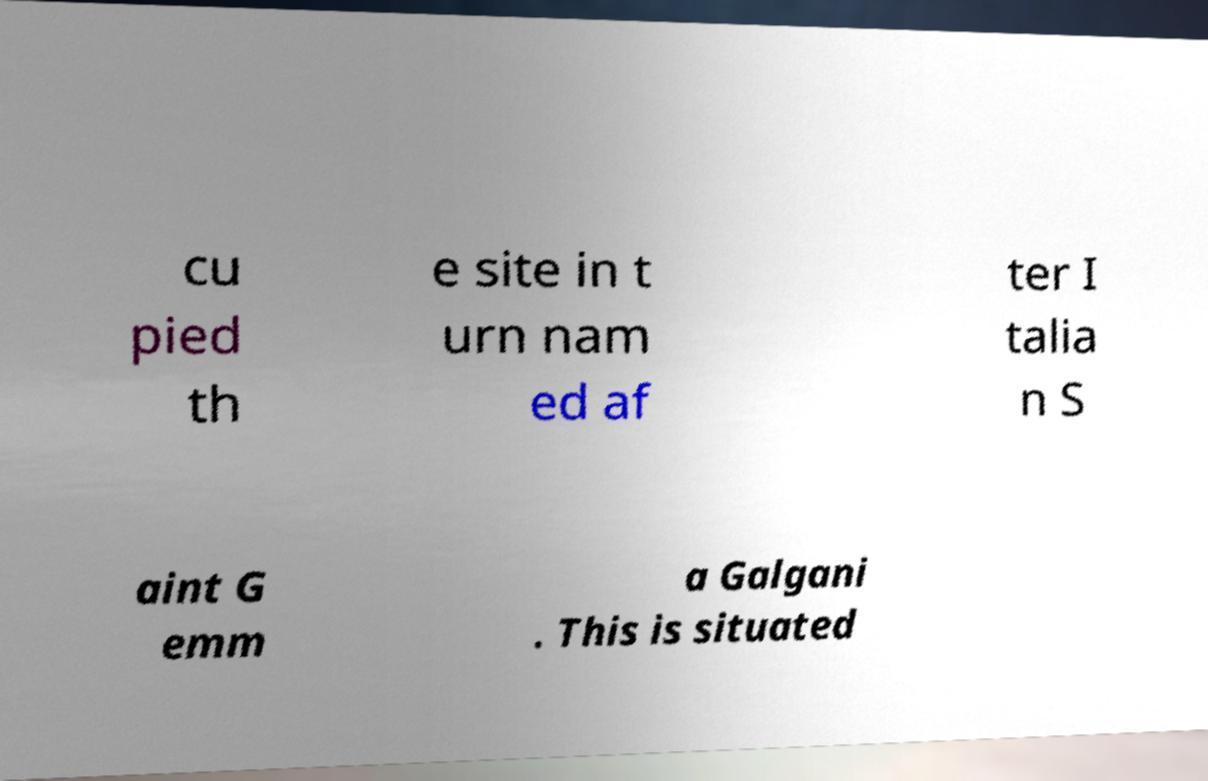Please read and relay the text visible in this image. What does it say? cu pied th e site in t urn nam ed af ter I talia n S aint G emm a Galgani . This is situated 